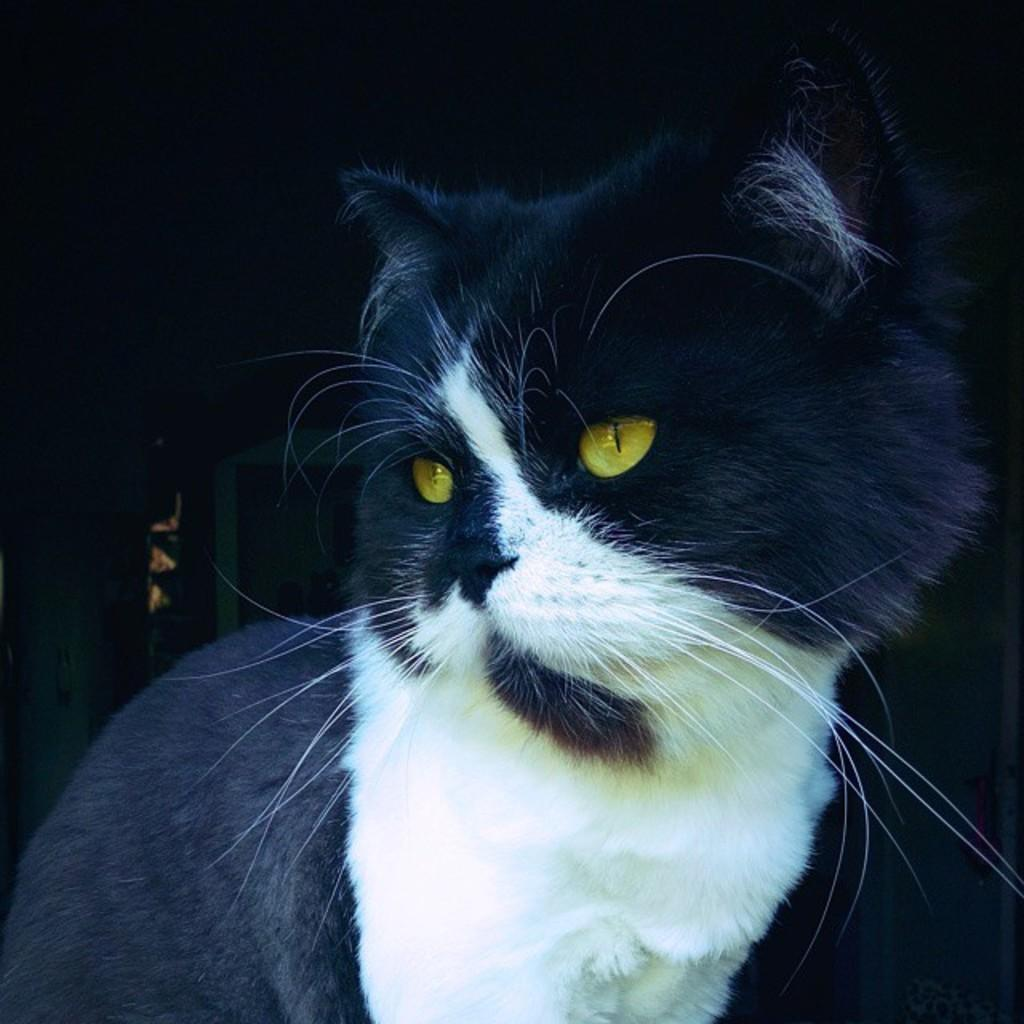What type of animal is in the image? There is a cat in the image. Can you describe the color pattern of the cat? The cat has white and black colors. What can be observed about the background of the image? The background of the image is dark. How many cows are present in the image? There are no cows present in the image; it features a cat. What type of selection process is being used to choose the cat's tail? There is no selection process being used to choose the cat's tail in the image, as it is a static photograph. 